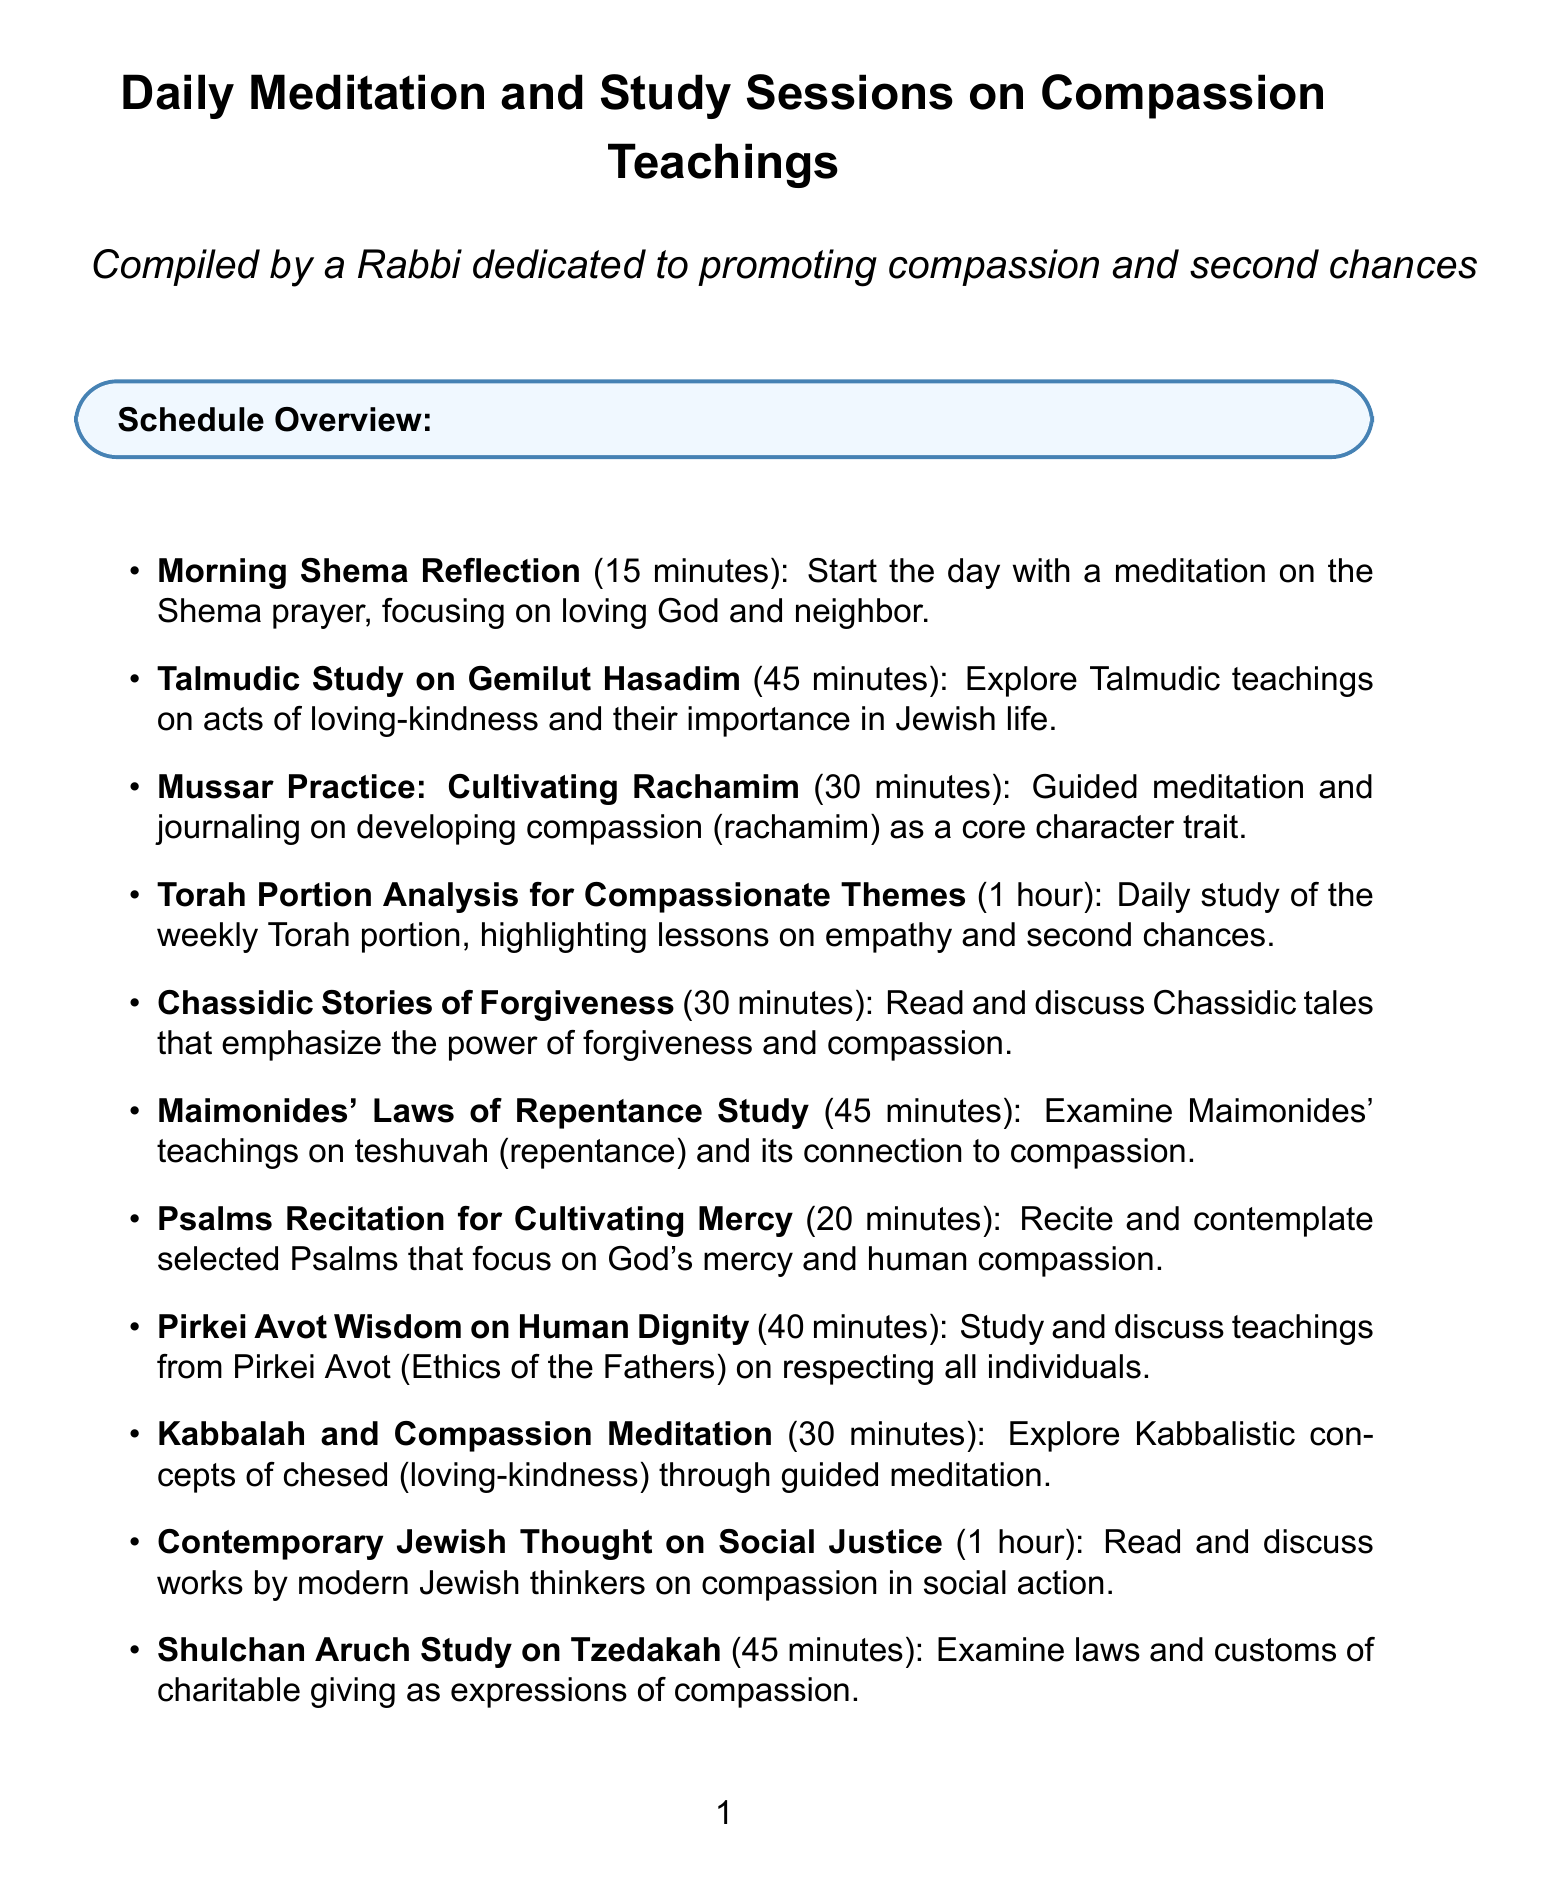What is the first session of the day? The first session is the Morning Shema Reflection, which starts the day with a meditation on the Shema prayer.
Answer: Morning Shema Reflection How long is the Talmudic Study on Gemilut Hasadim? The duration of the Talmudic Study on Gemilut Hasadim is mentioned in the schedule as 45 minutes.
Answer: 45 minutes What is the focus of the Mussar Practice session? The focus of the Mussar Practice session is on developing compassion (rachamim) as a core character trait through guided meditation and journaling.
Answer: Developing compassion Which session involves a study of modern Jewish thinkers? The session that involves a study of modern Jewish thinkers is the Contemporary Jewish Thought on Social Justice.
Answer: Contemporary Jewish Thought on Social Justice How many minutes are allocated for evening reflections on daily acts of kindness? The document states that 20 minutes are allocated for evening reflections on daily acts of kindness.
Answer: 20 minutes What theme does the Torah Portion Analysis session highlight? The Torah Portion Analysis for Compassionate Themes highlights lessons on empathy and second chances.
Answer: Empathy and second chances In which session are Psalms recited? Psalms Recitation for Cultivating Mercy is the session where selected Psalms are recited and contemplated.
Answer: Psalms Recitation for Cultivating Mercy What is the primary essence of the study sessions listed? The primary essence of the study sessions is to promote compassion and the idea of second chances in life.
Answer: Compassion and second chances 